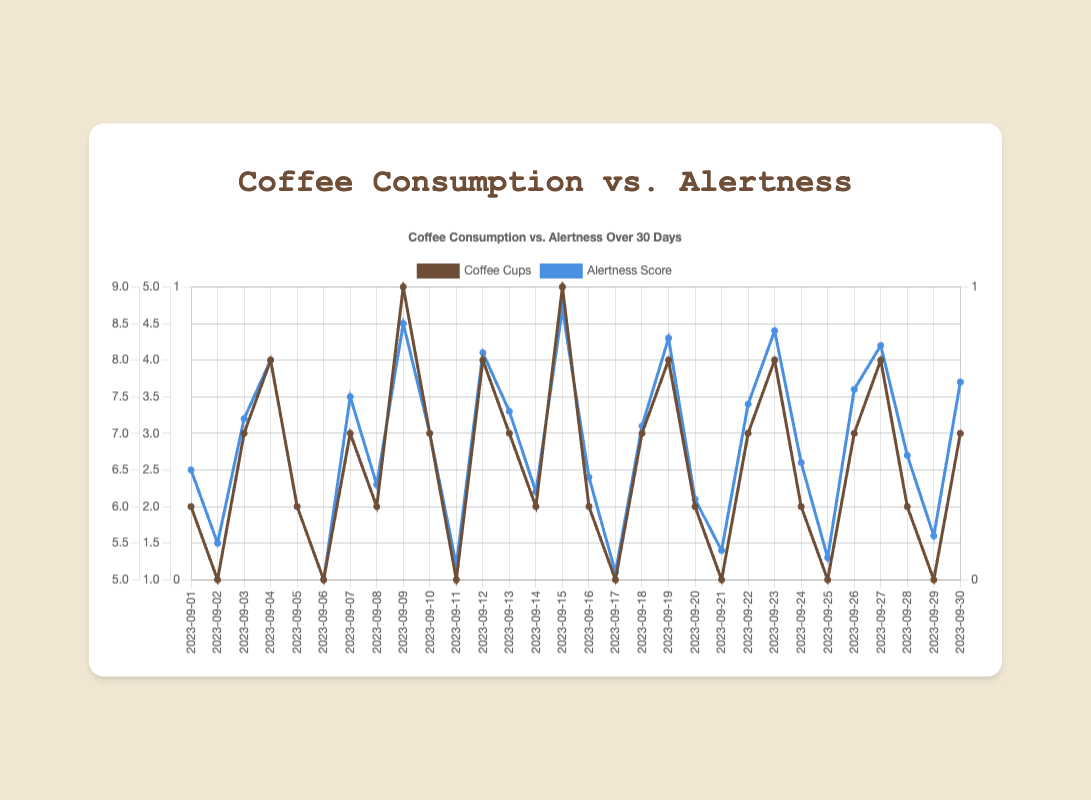What is the highest daily alertness score exhibited in the plot? The highest daily alertness score can be identified by looking at the peak value in the "Alertness Score" dataset on the plot. The peak alertness score is on 2023-09-15 with an alertness score of 8.7.
Answer: 8.7 On which day does the coffee consumption reach its maximum value and what is this value? The maximum value for coffee consumption is represented by the highest point in the "Coffee Cups" dataset. The highest coffee consumption occurs on two separate days, which are 2023-09-09 and 2023-09-15, with 5 cups each.
Answer: 2023-09-09 and 2023-09-15, 5 cups Is there any day when the alertness score is a perfect 10? Look through the "Alertness Score" dataset to see if any value reaches 10. From the plot, we can see that the highest alertness score is 8.7, which means that there is no day with a perfect score of 10.
Answer: No What is the average alertness score across all days? To find the average, add all the alertness scores together and divide by the total number of days (30). The sum of alertness scores is: 6.5+5.5+7.2+8.0+6.0+5.0+7.5+6.3+8.5+7.0+5.2+8.1+7.3+6.2+8.7+6.4+5.1+7.1+8.3+6.1+5.4+7.4+8.4+6.6+5.3+7.6+8.2+6.7+5.6+7.7 = 197.1. The average is therefore 197.1 / 30 = 6.57.
Answer: 6.57 How many days have a coffee consumption greater than or equal to 4 cups? Count the days on the "Coffee Cups" dataset where the value is 4 or more. The days that meet this condition are 2023-09-04, 2023-09-09, 2023-09-12, 2023-09-15, 2023-09-19, 2023-09-23, and 2023-09-27, resulting in 7 days.
Answer: 7 days How does the alertness score compare on days with 1 cup of coffee versus days with 4 cups of coffee? For days with 1 cup of coffee (2023-09-02, 2023-09-06, 2023-09-11, 2023-09-17, 2023-09-21, 2023-09-25, 2023-09-29), list the alertness scores: 5.5, 5.0, 5.2, 5.1, 5.4, 5.3, 5.6. The average is (5.5+5.0+5.2+5.1+5.4+5.3+5.6)/7 = 5.3. For days with 4 cups of coffee (2023-09-04, 2023-09-12, 2023-09-19, 2023-09-23, 2023-09-27), list the alertness scores: 8.0, 8.1, 8.3, 8.4, 8.2. The average is (8.0+8.1+8.3+8.4+8.2)/5 = 8.2.
Answer: 5.3 for 1 cup, 8.2 for 4 cups 